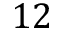<formula> <loc_0><loc_0><loc_500><loc_500>1 2</formula> 